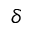Convert formula to latex. <formula><loc_0><loc_0><loc_500><loc_500>\delta</formula> 